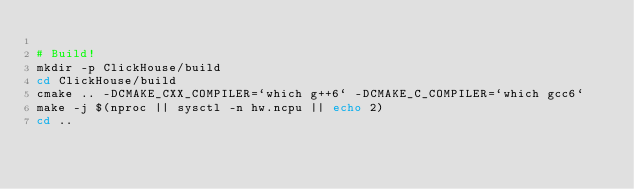Convert code to text. <code><loc_0><loc_0><loc_500><loc_500><_Bash_>
# Build!
mkdir -p ClickHouse/build
cd ClickHouse/build
cmake .. -DCMAKE_CXX_COMPILER=`which g++6` -DCMAKE_C_COMPILER=`which gcc6`
make -j $(nproc || sysctl -n hw.ncpu || echo 2)
cd ..
</code> 